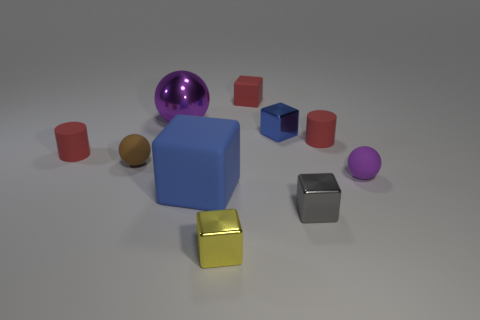What is the shape of the small metal object that is the same color as the large block?
Provide a short and direct response. Cube. Are there an equal number of purple metallic objects that are in front of the tiny brown matte sphere and blue things?
Make the answer very short. No. How big is the cylinder that is on the left side of the small gray shiny block?
Provide a succinct answer. Small. How many big things are either purple metallic balls or blue rubber objects?
Ensure brevity in your answer.  2. There is a tiny rubber thing that is the same shape as the blue metallic thing; what is its color?
Give a very brief answer. Red. Does the purple matte ball have the same size as the metallic sphere?
Ensure brevity in your answer.  No. What number of things are either small things or matte things to the right of the blue metal block?
Offer a terse response. 8. There is a ball that is right of the large blue cube that is in front of the brown rubber ball; what color is it?
Keep it short and to the point. Purple. Is the color of the tiny matte ball that is to the left of the small purple matte object the same as the large matte block?
Keep it short and to the point. No. What is the tiny red cylinder to the right of the metal ball made of?
Provide a short and direct response. Rubber. 